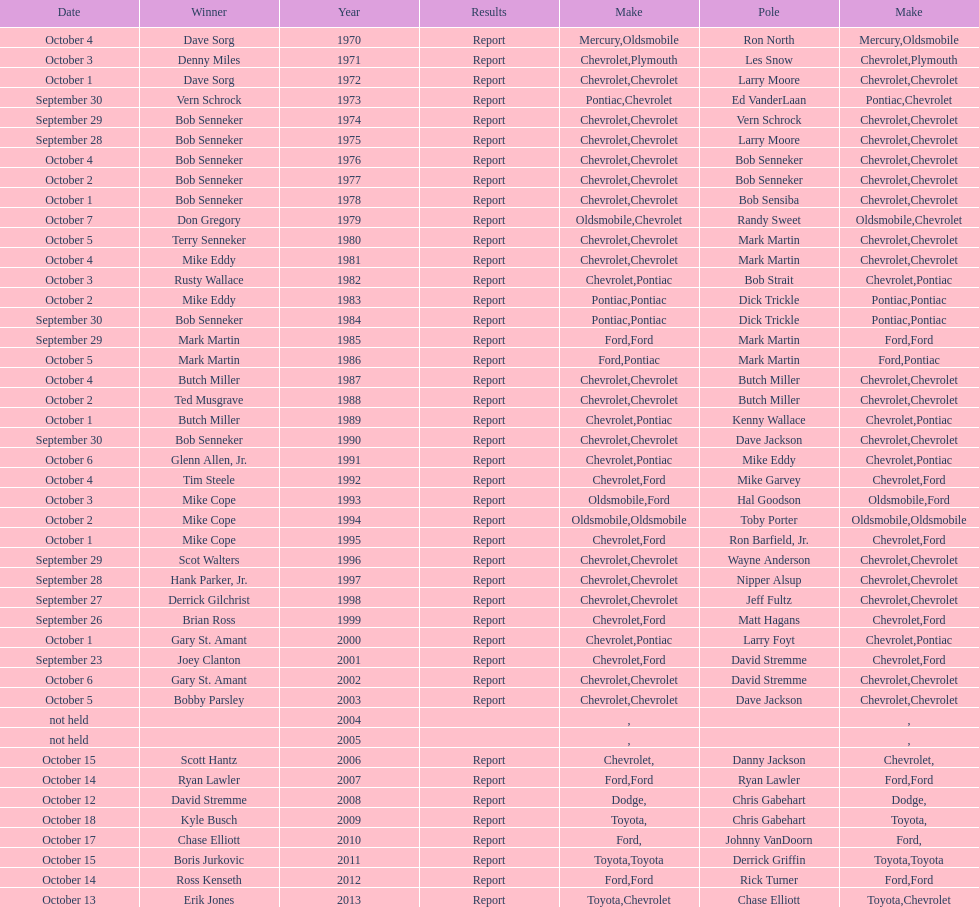How many consecutive wins did bob senneker have? 5. 